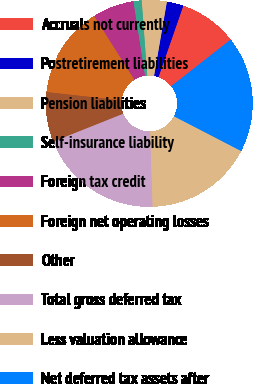Convert chart. <chart><loc_0><loc_0><loc_500><loc_500><pie_chart><fcel>Accruals not currently<fcel>Postretirement liabilities<fcel>Pension liabilities<fcel>Self-insurance liability<fcel>Foreign tax credit<fcel>Foreign net operating losses<fcel>Other<fcel>Total gross deferred tax<fcel>Less valuation allowance<fcel>Net deferred tax assets after<nl><fcel>9.09%<fcel>2.6%<fcel>3.9%<fcel>1.3%<fcel>6.5%<fcel>14.28%<fcel>7.79%<fcel>19.48%<fcel>16.88%<fcel>18.18%<nl></chart> 